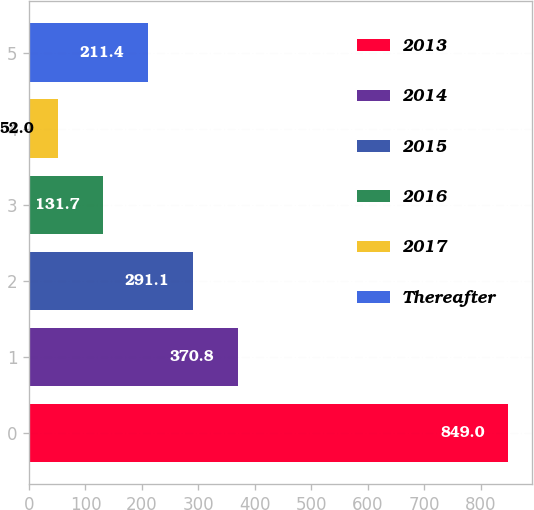Convert chart to OTSL. <chart><loc_0><loc_0><loc_500><loc_500><bar_chart><fcel>2013<fcel>2014<fcel>2015<fcel>2016<fcel>2017<fcel>Thereafter<nl><fcel>849<fcel>370.8<fcel>291.1<fcel>131.7<fcel>52<fcel>211.4<nl></chart> 